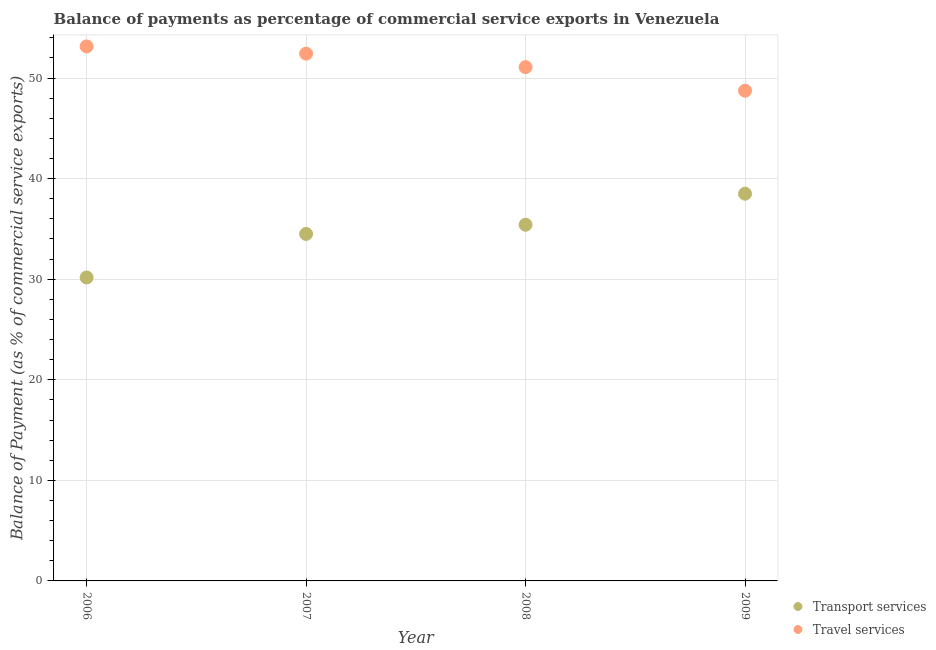How many different coloured dotlines are there?
Ensure brevity in your answer.  2. What is the balance of payments of transport services in 2006?
Keep it short and to the point. 30.17. Across all years, what is the maximum balance of payments of travel services?
Your response must be concise. 53.15. Across all years, what is the minimum balance of payments of travel services?
Give a very brief answer. 48.74. In which year was the balance of payments of travel services minimum?
Ensure brevity in your answer.  2009. What is the total balance of payments of travel services in the graph?
Provide a succinct answer. 205.42. What is the difference between the balance of payments of travel services in 2008 and that in 2009?
Ensure brevity in your answer.  2.35. What is the difference between the balance of payments of travel services in 2007 and the balance of payments of transport services in 2008?
Keep it short and to the point. 17.01. What is the average balance of payments of travel services per year?
Make the answer very short. 51.35. In the year 2008, what is the difference between the balance of payments of transport services and balance of payments of travel services?
Provide a succinct answer. -15.67. In how many years, is the balance of payments of transport services greater than 38 %?
Make the answer very short. 1. What is the ratio of the balance of payments of travel services in 2007 to that in 2008?
Offer a very short reply. 1.03. What is the difference between the highest and the second highest balance of payments of transport services?
Your answer should be compact. 3.09. What is the difference between the highest and the lowest balance of payments of travel services?
Provide a succinct answer. 4.4. In how many years, is the balance of payments of travel services greater than the average balance of payments of travel services taken over all years?
Ensure brevity in your answer.  2. Is the sum of the balance of payments of transport services in 2007 and 2009 greater than the maximum balance of payments of travel services across all years?
Make the answer very short. Yes. Does the balance of payments of travel services monotonically increase over the years?
Ensure brevity in your answer.  No. Is the balance of payments of travel services strictly greater than the balance of payments of transport services over the years?
Ensure brevity in your answer.  Yes. Is the balance of payments of travel services strictly less than the balance of payments of transport services over the years?
Provide a short and direct response. No. How many years are there in the graph?
Your response must be concise. 4. Are the values on the major ticks of Y-axis written in scientific E-notation?
Provide a succinct answer. No. Does the graph contain any zero values?
Provide a succinct answer. No. How many legend labels are there?
Provide a short and direct response. 2. What is the title of the graph?
Your response must be concise. Balance of payments as percentage of commercial service exports in Venezuela. Does "Total Population" appear as one of the legend labels in the graph?
Provide a succinct answer. No. What is the label or title of the Y-axis?
Offer a very short reply. Balance of Payment (as % of commercial service exports). What is the Balance of Payment (as % of commercial service exports) of Transport services in 2006?
Provide a short and direct response. 30.17. What is the Balance of Payment (as % of commercial service exports) in Travel services in 2006?
Offer a terse response. 53.15. What is the Balance of Payment (as % of commercial service exports) in Transport services in 2007?
Offer a very short reply. 34.5. What is the Balance of Payment (as % of commercial service exports) of Travel services in 2007?
Offer a terse response. 52.43. What is the Balance of Payment (as % of commercial service exports) in Transport services in 2008?
Give a very brief answer. 35.42. What is the Balance of Payment (as % of commercial service exports) of Travel services in 2008?
Offer a terse response. 51.09. What is the Balance of Payment (as % of commercial service exports) of Transport services in 2009?
Offer a terse response. 38.5. What is the Balance of Payment (as % of commercial service exports) in Travel services in 2009?
Your answer should be compact. 48.74. Across all years, what is the maximum Balance of Payment (as % of commercial service exports) in Transport services?
Make the answer very short. 38.5. Across all years, what is the maximum Balance of Payment (as % of commercial service exports) in Travel services?
Make the answer very short. 53.15. Across all years, what is the minimum Balance of Payment (as % of commercial service exports) in Transport services?
Make the answer very short. 30.17. Across all years, what is the minimum Balance of Payment (as % of commercial service exports) of Travel services?
Keep it short and to the point. 48.74. What is the total Balance of Payment (as % of commercial service exports) of Transport services in the graph?
Keep it short and to the point. 138.6. What is the total Balance of Payment (as % of commercial service exports) in Travel services in the graph?
Provide a short and direct response. 205.42. What is the difference between the Balance of Payment (as % of commercial service exports) of Transport services in 2006 and that in 2007?
Offer a terse response. -4.33. What is the difference between the Balance of Payment (as % of commercial service exports) in Travel services in 2006 and that in 2007?
Ensure brevity in your answer.  0.72. What is the difference between the Balance of Payment (as % of commercial service exports) of Transport services in 2006 and that in 2008?
Ensure brevity in your answer.  -5.24. What is the difference between the Balance of Payment (as % of commercial service exports) in Travel services in 2006 and that in 2008?
Offer a terse response. 2.06. What is the difference between the Balance of Payment (as % of commercial service exports) of Transport services in 2006 and that in 2009?
Keep it short and to the point. -8.33. What is the difference between the Balance of Payment (as % of commercial service exports) of Travel services in 2006 and that in 2009?
Your answer should be very brief. 4.4. What is the difference between the Balance of Payment (as % of commercial service exports) of Transport services in 2007 and that in 2008?
Offer a very short reply. -0.91. What is the difference between the Balance of Payment (as % of commercial service exports) in Travel services in 2007 and that in 2008?
Your answer should be compact. 1.34. What is the difference between the Balance of Payment (as % of commercial service exports) of Transport services in 2007 and that in 2009?
Provide a succinct answer. -4. What is the difference between the Balance of Payment (as % of commercial service exports) of Travel services in 2007 and that in 2009?
Ensure brevity in your answer.  3.69. What is the difference between the Balance of Payment (as % of commercial service exports) of Transport services in 2008 and that in 2009?
Your answer should be compact. -3.09. What is the difference between the Balance of Payment (as % of commercial service exports) of Travel services in 2008 and that in 2009?
Keep it short and to the point. 2.35. What is the difference between the Balance of Payment (as % of commercial service exports) in Transport services in 2006 and the Balance of Payment (as % of commercial service exports) in Travel services in 2007?
Your answer should be very brief. -22.26. What is the difference between the Balance of Payment (as % of commercial service exports) in Transport services in 2006 and the Balance of Payment (as % of commercial service exports) in Travel services in 2008?
Keep it short and to the point. -20.92. What is the difference between the Balance of Payment (as % of commercial service exports) of Transport services in 2006 and the Balance of Payment (as % of commercial service exports) of Travel services in 2009?
Ensure brevity in your answer.  -18.57. What is the difference between the Balance of Payment (as % of commercial service exports) of Transport services in 2007 and the Balance of Payment (as % of commercial service exports) of Travel services in 2008?
Make the answer very short. -16.59. What is the difference between the Balance of Payment (as % of commercial service exports) in Transport services in 2007 and the Balance of Payment (as % of commercial service exports) in Travel services in 2009?
Ensure brevity in your answer.  -14.24. What is the difference between the Balance of Payment (as % of commercial service exports) in Transport services in 2008 and the Balance of Payment (as % of commercial service exports) in Travel services in 2009?
Your answer should be very brief. -13.33. What is the average Balance of Payment (as % of commercial service exports) in Transport services per year?
Your answer should be very brief. 34.65. What is the average Balance of Payment (as % of commercial service exports) in Travel services per year?
Provide a short and direct response. 51.35. In the year 2006, what is the difference between the Balance of Payment (as % of commercial service exports) of Transport services and Balance of Payment (as % of commercial service exports) of Travel services?
Your response must be concise. -22.98. In the year 2007, what is the difference between the Balance of Payment (as % of commercial service exports) in Transport services and Balance of Payment (as % of commercial service exports) in Travel services?
Keep it short and to the point. -17.93. In the year 2008, what is the difference between the Balance of Payment (as % of commercial service exports) in Transport services and Balance of Payment (as % of commercial service exports) in Travel services?
Give a very brief answer. -15.67. In the year 2009, what is the difference between the Balance of Payment (as % of commercial service exports) in Transport services and Balance of Payment (as % of commercial service exports) in Travel services?
Keep it short and to the point. -10.24. What is the ratio of the Balance of Payment (as % of commercial service exports) of Transport services in 2006 to that in 2007?
Offer a very short reply. 0.87. What is the ratio of the Balance of Payment (as % of commercial service exports) of Travel services in 2006 to that in 2007?
Offer a terse response. 1.01. What is the ratio of the Balance of Payment (as % of commercial service exports) in Transport services in 2006 to that in 2008?
Offer a terse response. 0.85. What is the ratio of the Balance of Payment (as % of commercial service exports) in Travel services in 2006 to that in 2008?
Offer a terse response. 1.04. What is the ratio of the Balance of Payment (as % of commercial service exports) of Transport services in 2006 to that in 2009?
Ensure brevity in your answer.  0.78. What is the ratio of the Balance of Payment (as % of commercial service exports) in Travel services in 2006 to that in 2009?
Keep it short and to the point. 1.09. What is the ratio of the Balance of Payment (as % of commercial service exports) in Transport services in 2007 to that in 2008?
Your answer should be compact. 0.97. What is the ratio of the Balance of Payment (as % of commercial service exports) in Travel services in 2007 to that in 2008?
Keep it short and to the point. 1.03. What is the ratio of the Balance of Payment (as % of commercial service exports) in Transport services in 2007 to that in 2009?
Your response must be concise. 0.9. What is the ratio of the Balance of Payment (as % of commercial service exports) of Travel services in 2007 to that in 2009?
Provide a succinct answer. 1.08. What is the ratio of the Balance of Payment (as % of commercial service exports) of Transport services in 2008 to that in 2009?
Keep it short and to the point. 0.92. What is the ratio of the Balance of Payment (as % of commercial service exports) in Travel services in 2008 to that in 2009?
Offer a terse response. 1.05. What is the difference between the highest and the second highest Balance of Payment (as % of commercial service exports) in Transport services?
Provide a succinct answer. 3.09. What is the difference between the highest and the second highest Balance of Payment (as % of commercial service exports) in Travel services?
Your response must be concise. 0.72. What is the difference between the highest and the lowest Balance of Payment (as % of commercial service exports) of Transport services?
Make the answer very short. 8.33. What is the difference between the highest and the lowest Balance of Payment (as % of commercial service exports) of Travel services?
Give a very brief answer. 4.4. 